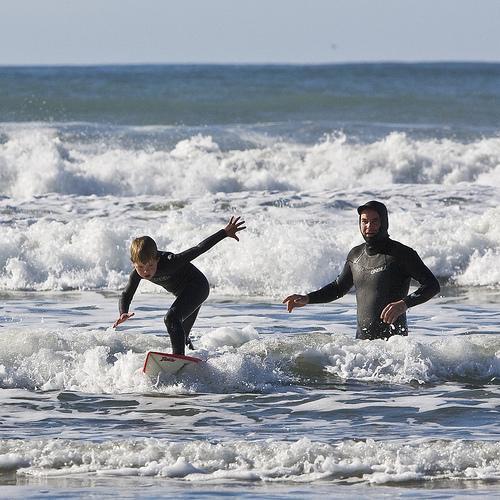How many people are there?
Give a very brief answer. 2. 